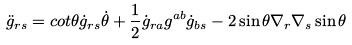<formula> <loc_0><loc_0><loc_500><loc_500>\ddot { g } _ { r s } = c o t \theta \dot { g } _ { r s } \dot { \theta } + \frac { 1 } { 2 } \dot { g } _ { r a } g ^ { a b } \dot { g } _ { b s } - 2 \sin \theta \nabla _ { r } \nabla _ { s } \sin \theta</formula> 